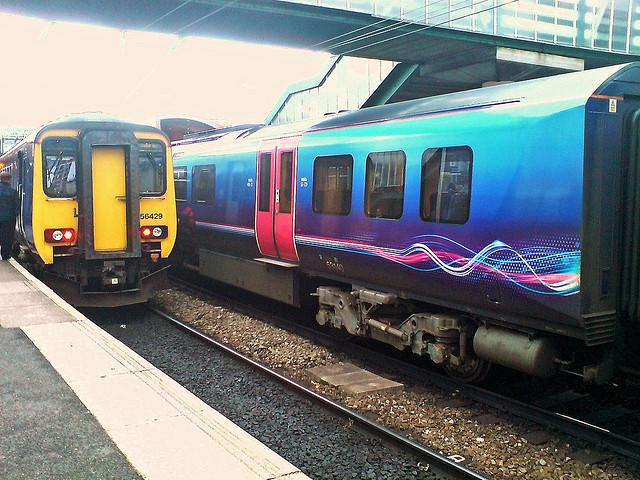What structure is present above the parked trains on the rail tracks? bridge 